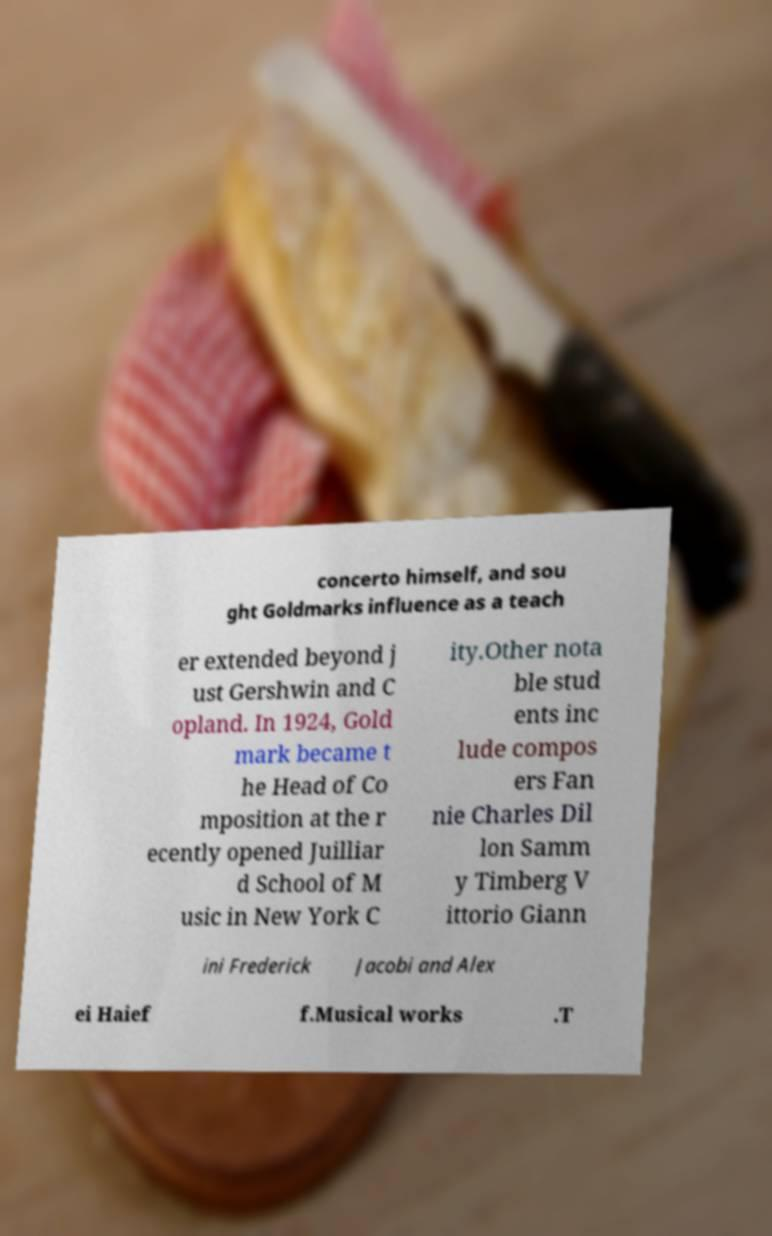Can you accurately transcribe the text from the provided image for me? concerto himself, and sou ght Goldmarks influence as a teach er extended beyond j ust Gershwin and C opland. In 1924, Gold mark became t he Head of Co mposition at the r ecently opened Juilliar d School of M usic in New York C ity.Other nota ble stud ents inc lude compos ers Fan nie Charles Dil lon Samm y Timberg V ittorio Giann ini Frederick Jacobi and Alex ei Haief f.Musical works .T 